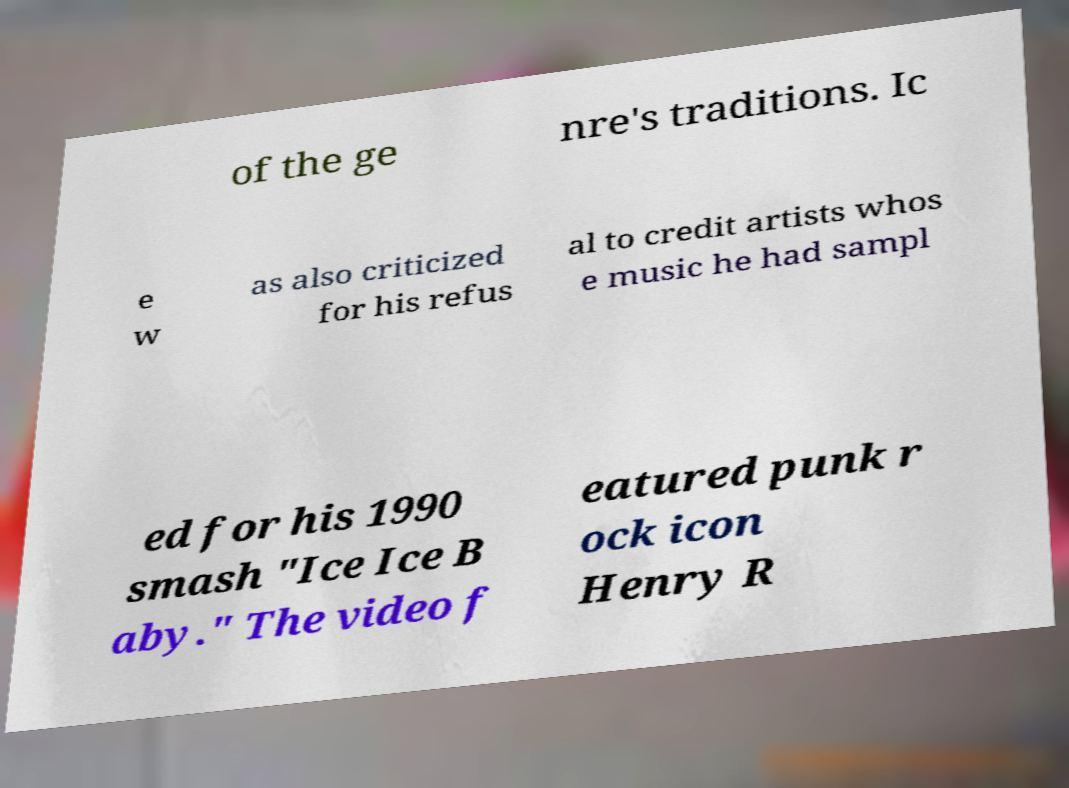Please read and relay the text visible in this image. What does it say? of the ge nre's traditions. Ic e w as also criticized for his refus al to credit artists whos e music he had sampl ed for his 1990 smash "Ice Ice B aby." The video f eatured punk r ock icon Henry R 